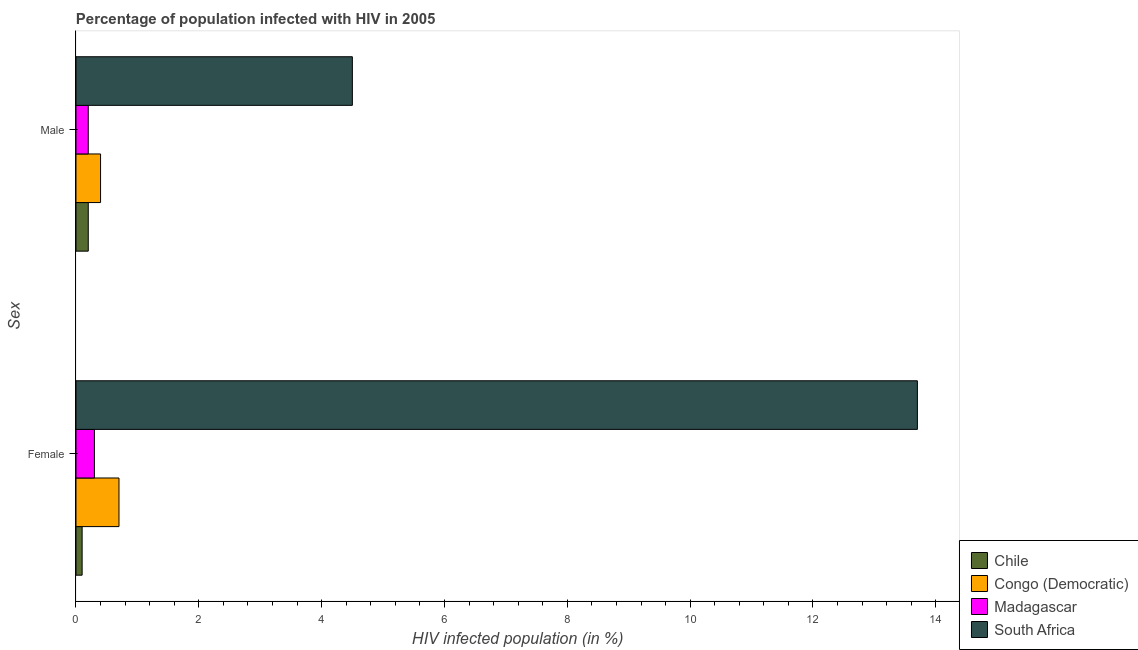Are the number of bars per tick equal to the number of legend labels?
Keep it short and to the point. Yes. How many bars are there on the 2nd tick from the bottom?
Your answer should be very brief. 4. What is the label of the 2nd group of bars from the top?
Keep it short and to the point. Female. What is the percentage of females who are infected with hiv in Chile?
Offer a very short reply. 0.1. Across all countries, what is the maximum percentage of males who are infected with hiv?
Provide a succinct answer. 4.5. Across all countries, what is the minimum percentage of females who are infected with hiv?
Your answer should be very brief. 0.1. In which country was the percentage of males who are infected with hiv maximum?
Offer a terse response. South Africa. In which country was the percentage of males who are infected with hiv minimum?
Offer a terse response. Chile. What is the total percentage of males who are infected with hiv in the graph?
Your answer should be compact. 5.3. What is the difference between the percentage of males who are infected with hiv in South Africa and that in Madagascar?
Your answer should be very brief. 4.3. What is the difference between the percentage of females who are infected with hiv in Chile and the percentage of males who are infected with hiv in Congo (Democratic)?
Offer a terse response. -0.3. What is the average percentage of females who are infected with hiv per country?
Your answer should be compact. 3.7. What is the difference between the percentage of females who are infected with hiv and percentage of males who are infected with hiv in Madagascar?
Ensure brevity in your answer.  0.1. In how many countries, is the percentage of males who are infected with hiv greater than 11.6 %?
Offer a terse response. 0. What is the ratio of the percentage of males who are infected with hiv in South Africa to that in Congo (Democratic)?
Provide a short and direct response. 11.25. What does the 4th bar from the top in Female represents?
Offer a terse response. Chile. How many bars are there?
Your response must be concise. 8. What is the difference between two consecutive major ticks on the X-axis?
Ensure brevity in your answer.  2. Does the graph contain grids?
Provide a short and direct response. No. How many legend labels are there?
Ensure brevity in your answer.  4. How are the legend labels stacked?
Your answer should be very brief. Vertical. What is the title of the graph?
Offer a very short reply. Percentage of population infected with HIV in 2005. What is the label or title of the X-axis?
Provide a succinct answer. HIV infected population (in %). What is the label or title of the Y-axis?
Keep it short and to the point. Sex. What is the HIV infected population (in %) of Chile in Female?
Offer a very short reply. 0.1. What is the HIV infected population (in %) in Chile in Male?
Ensure brevity in your answer.  0.2. What is the HIV infected population (in %) of South Africa in Male?
Offer a very short reply. 4.5. Across all Sex, what is the maximum HIV infected population (in %) in Chile?
Your answer should be compact. 0.2. Across all Sex, what is the maximum HIV infected population (in %) of Madagascar?
Provide a succinct answer. 0.3. Across all Sex, what is the minimum HIV infected population (in %) of South Africa?
Provide a succinct answer. 4.5. What is the total HIV infected population (in %) in Madagascar in the graph?
Offer a terse response. 0.5. What is the difference between the HIV infected population (in %) of Congo (Democratic) in Female and that in Male?
Provide a succinct answer. 0.3. What is the difference between the HIV infected population (in %) of Madagascar in Female and that in Male?
Offer a very short reply. 0.1. What is the difference between the HIV infected population (in %) in South Africa in Female and that in Male?
Ensure brevity in your answer.  9.2. What is the difference between the HIV infected population (in %) of Chile in Female and the HIV infected population (in %) of Madagascar in Male?
Make the answer very short. -0.1. What is the average HIV infected population (in %) in Congo (Democratic) per Sex?
Ensure brevity in your answer.  0.55. What is the difference between the HIV infected population (in %) in Chile and HIV infected population (in %) in Congo (Democratic) in Female?
Your answer should be very brief. -0.6. What is the difference between the HIV infected population (in %) of Congo (Democratic) and HIV infected population (in %) of Madagascar in Female?
Offer a very short reply. 0.4. What is the difference between the HIV infected population (in %) in Congo (Democratic) and HIV infected population (in %) in South Africa in Female?
Provide a short and direct response. -13. What is the difference between the HIV infected population (in %) of Chile and HIV infected population (in %) of South Africa in Male?
Offer a terse response. -4.3. What is the difference between the HIV infected population (in %) of Congo (Democratic) and HIV infected population (in %) of South Africa in Male?
Your answer should be compact. -4.1. What is the difference between the HIV infected population (in %) of Madagascar and HIV infected population (in %) of South Africa in Male?
Offer a very short reply. -4.3. What is the ratio of the HIV infected population (in %) in Congo (Democratic) in Female to that in Male?
Keep it short and to the point. 1.75. What is the ratio of the HIV infected population (in %) in Madagascar in Female to that in Male?
Provide a succinct answer. 1.5. What is the ratio of the HIV infected population (in %) of South Africa in Female to that in Male?
Make the answer very short. 3.04. What is the difference between the highest and the second highest HIV infected population (in %) of Madagascar?
Offer a very short reply. 0.1. What is the difference between the highest and the lowest HIV infected population (in %) in Congo (Democratic)?
Give a very brief answer. 0.3. 